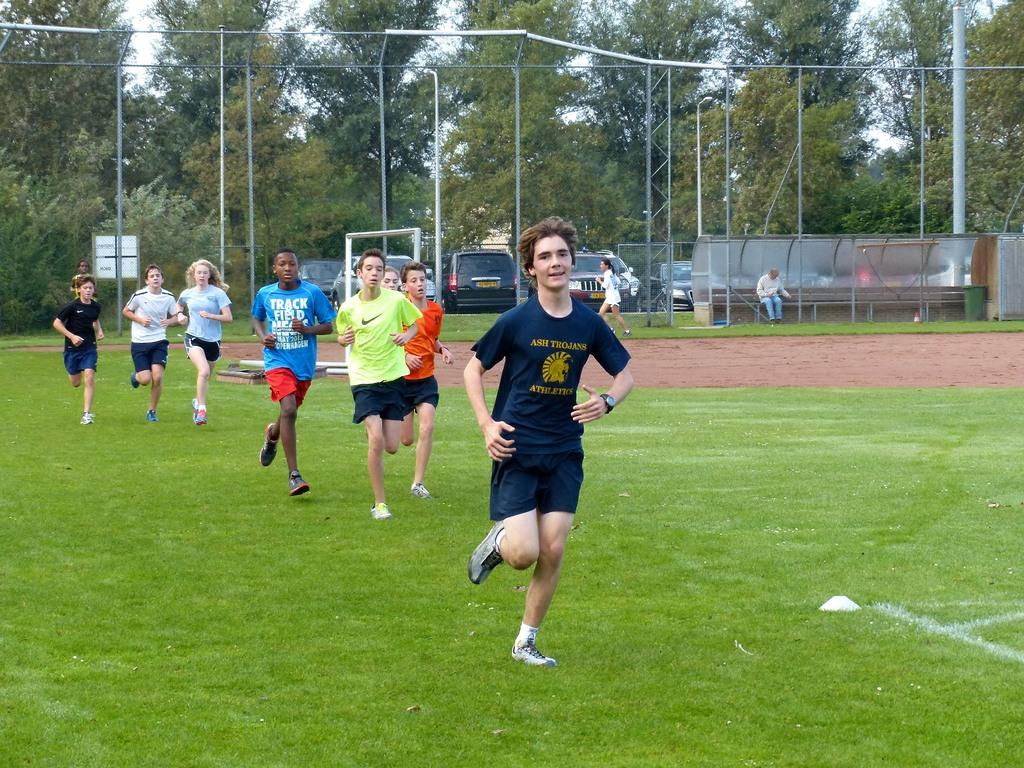<image>
Relay a brief, clear account of the picture shown. the word ash is on the front of a person's shirt 